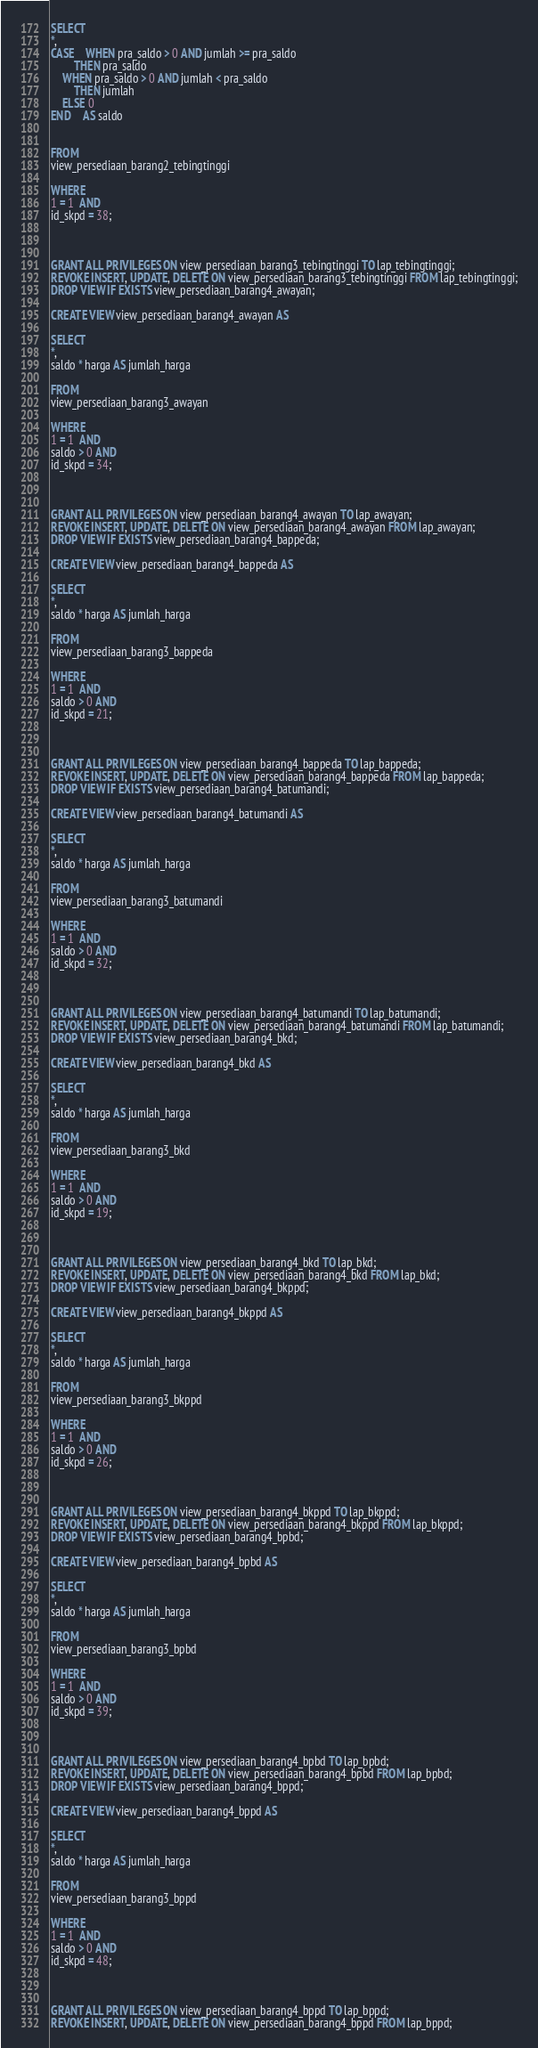<code> <loc_0><loc_0><loc_500><loc_500><_SQL_>
SELECT
*,
CASE	WHEN pra_saldo > 0 AND jumlah >= pra_saldo
	    THEN pra_saldo
	WHEN pra_saldo > 0 AND jumlah < pra_saldo
	    THEN jumlah
	ELSE 0
END	AS saldo


FROM
view_persediaan_barang2_tebingtinggi

WHERE
1 = 1  AND
id_skpd = 38;



GRANT ALL PRIVILEGES ON view_persediaan_barang3_tebingtinggi TO lap_tebingtinggi;
REVOKE INSERT, UPDATE, DELETE ON view_persediaan_barang3_tebingtinggi FROM lap_tebingtinggi;
DROP VIEW IF EXISTS view_persediaan_barang4_awayan;

CREATE VIEW view_persediaan_barang4_awayan AS

SELECT
*,
saldo * harga AS jumlah_harga

FROM
view_persediaan_barang3_awayan

WHERE
1 = 1  AND
saldo > 0 AND
id_skpd = 34;



GRANT ALL PRIVILEGES ON view_persediaan_barang4_awayan TO lap_awayan;
REVOKE INSERT, UPDATE, DELETE ON view_persediaan_barang4_awayan FROM lap_awayan;
DROP VIEW IF EXISTS view_persediaan_barang4_bappeda;

CREATE VIEW view_persediaan_barang4_bappeda AS

SELECT
*,
saldo * harga AS jumlah_harga

FROM
view_persediaan_barang3_bappeda

WHERE
1 = 1  AND
saldo > 0 AND
id_skpd = 21;



GRANT ALL PRIVILEGES ON view_persediaan_barang4_bappeda TO lap_bappeda;
REVOKE INSERT, UPDATE, DELETE ON view_persediaan_barang4_bappeda FROM lap_bappeda;
DROP VIEW IF EXISTS view_persediaan_barang4_batumandi;

CREATE VIEW view_persediaan_barang4_batumandi AS

SELECT
*,
saldo * harga AS jumlah_harga

FROM
view_persediaan_barang3_batumandi

WHERE
1 = 1  AND
saldo > 0 AND
id_skpd = 32;



GRANT ALL PRIVILEGES ON view_persediaan_barang4_batumandi TO lap_batumandi;
REVOKE INSERT, UPDATE, DELETE ON view_persediaan_barang4_batumandi FROM lap_batumandi;
DROP VIEW IF EXISTS view_persediaan_barang4_bkd;

CREATE VIEW view_persediaan_barang4_bkd AS

SELECT
*,
saldo * harga AS jumlah_harga

FROM
view_persediaan_barang3_bkd

WHERE
1 = 1  AND
saldo > 0 AND
id_skpd = 19;



GRANT ALL PRIVILEGES ON view_persediaan_barang4_bkd TO lap_bkd;
REVOKE INSERT, UPDATE, DELETE ON view_persediaan_barang4_bkd FROM lap_bkd;
DROP VIEW IF EXISTS view_persediaan_barang4_bkppd;

CREATE VIEW view_persediaan_barang4_bkppd AS

SELECT
*,
saldo * harga AS jumlah_harga

FROM
view_persediaan_barang3_bkppd

WHERE
1 = 1  AND
saldo > 0 AND
id_skpd = 26;



GRANT ALL PRIVILEGES ON view_persediaan_barang4_bkppd TO lap_bkppd;
REVOKE INSERT, UPDATE, DELETE ON view_persediaan_barang4_bkppd FROM lap_bkppd;
DROP VIEW IF EXISTS view_persediaan_barang4_bpbd;

CREATE VIEW view_persediaan_barang4_bpbd AS

SELECT
*,
saldo * harga AS jumlah_harga

FROM
view_persediaan_barang3_bpbd

WHERE
1 = 1  AND
saldo > 0 AND
id_skpd = 39;



GRANT ALL PRIVILEGES ON view_persediaan_barang4_bpbd TO lap_bpbd;
REVOKE INSERT, UPDATE, DELETE ON view_persediaan_barang4_bpbd FROM lap_bpbd;
DROP VIEW IF EXISTS view_persediaan_barang4_bppd;

CREATE VIEW view_persediaan_barang4_bppd AS

SELECT
*,
saldo * harga AS jumlah_harga

FROM
view_persediaan_barang3_bppd

WHERE
1 = 1  AND
saldo > 0 AND
id_skpd = 48;



GRANT ALL PRIVILEGES ON view_persediaan_barang4_bppd TO lap_bppd;
REVOKE INSERT, UPDATE, DELETE ON view_persediaan_barang4_bppd FROM lap_bppd;</code> 